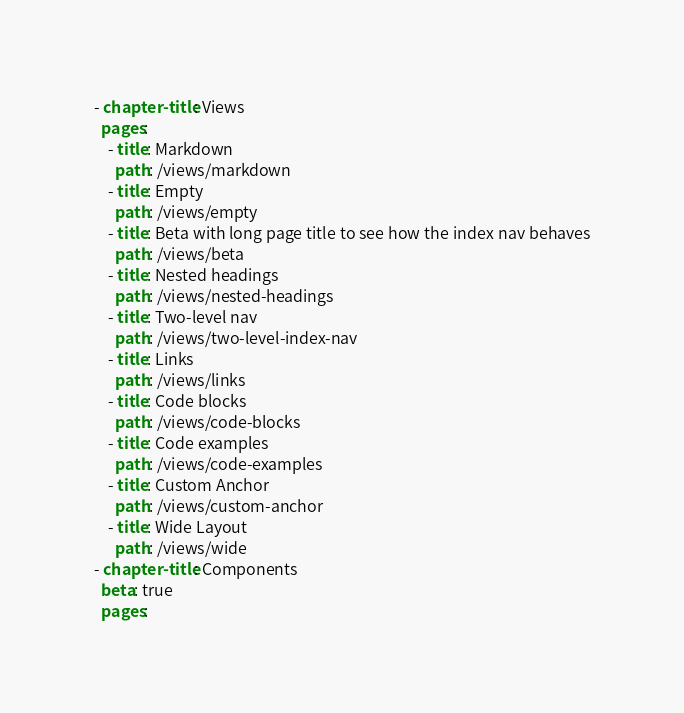<code> <loc_0><loc_0><loc_500><loc_500><_YAML_>- chapter-title: Views
  pages:
    - title: Markdown
      path: /views/markdown
    - title: Empty
      path: /views/empty
    - title: Beta with long page title to see how the index nav behaves
      path: /views/beta
    - title: Nested headings
      path: /views/nested-headings
    - title: Two-level nav
      path: /views/two-level-index-nav
    - title: Links
      path: /views/links
    - title: Code blocks
      path: /views/code-blocks
    - title: Code examples
      path: /views/code-examples
    - title: Custom Anchor
      path: /views/custom-anchor
    - title: Wide Layout
      path: /views/wide
- chapter-title: Components
  beta: true
  pages:</code> 